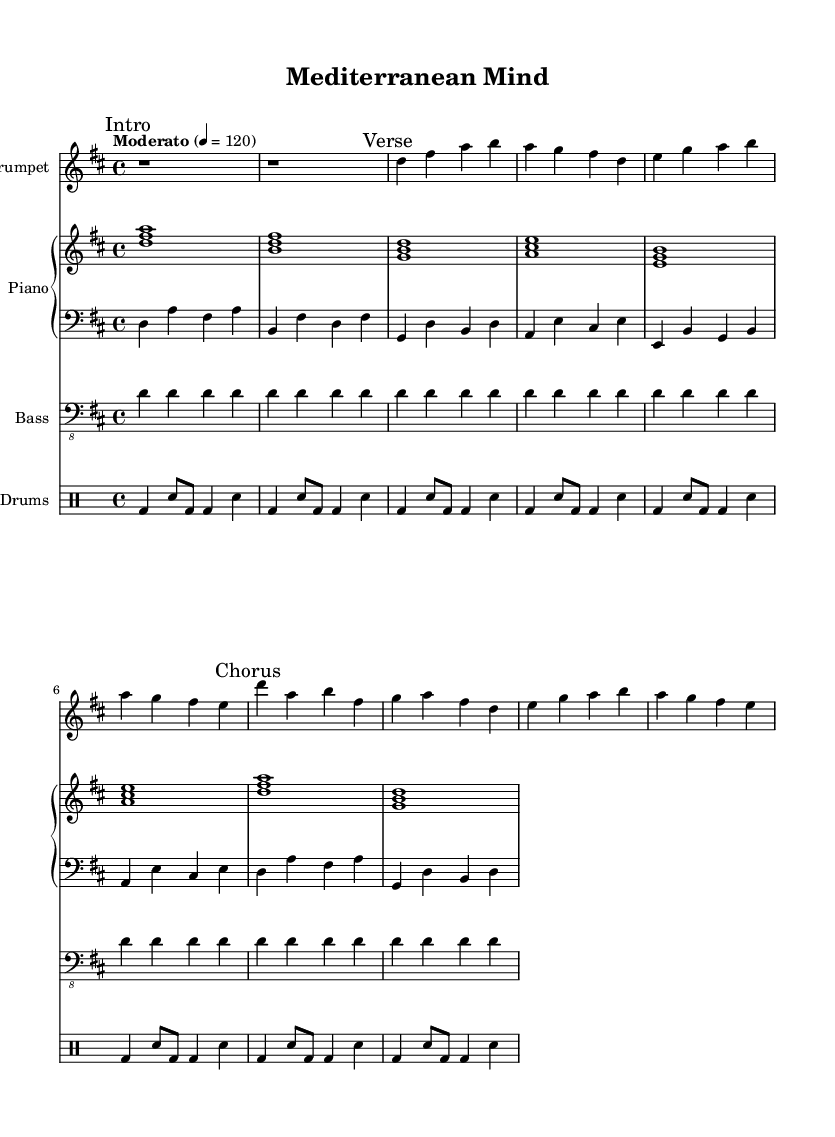What is the key signature of this music? The key signature is D major, which has two sharps: F# and C#.
Answer: D major What is the time signature of this piece? The time signature is 4/4, indicating four beats per measure.
Answer: 4/4 What is the tempo marking? The tempo marking is "Moderato" with a beat of 120.
Answer: Moderato How many measures are in the "Intro" section? The "Intro" section consists of 2 measures, as indicated by the rests.
Answer: 2 Which instruments are featured in this composition? The instruments featured are Trumpet, Piano, Bass, and Drums.
Answer: Trumpet, Piano, Bass, Drums What is the harmonic progression in the "Chorus" section? The harmonic progression includes D, B, F#, G, A, and E, based on the chords played.
Answer: D, B, F#, G, A, E What musical genre does this piece represent? This piece represents the fusion of Latin jazz and Mediterranean influences.
Answer: Latin-jazz fusion 